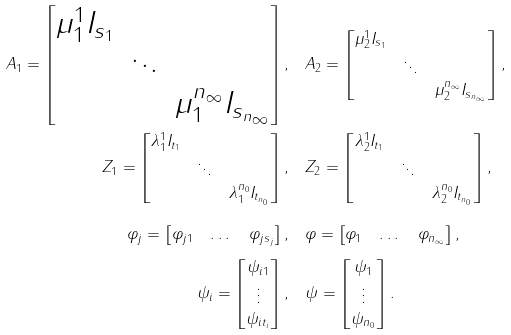<formula> <loc_0><loc_0><loc_500><loc_500>A _ { 1 } = \begin{bmatrix} \mu ^ { 1 } _ { 1 } I _ { s _ { 1 } } & & \\ & \ddots & \\ & & \mu ^ { n _ { \infty } } _ { 1 } I _ { s _ { n _ { \infty } } } \end{bmatrix} , & \quad A _ { 2 } = \begin{bmatrix} \mu ^ { 1 } _ { 2 } I _ { s _ { 1 } } & & \\ & \ddots & \\ & & \mu ^ { n _ { \infty } } _ { 2 } I _ { s _ { n _ { \infty } } } \end{bmatrix} , \\ Z _ { 1 } = \begin{bmatrix} \lambda ^ { 1 } _ { 1 } I _ { t _ { 1 } } & & \\ & \ddots & \\ & & \lambda ^ { n _ { 0 } } _ { 1 } I _ { t _ { n _ { 0 } } } \end{bmatrix} , & \quad Z _ { 2 } = \begin{bmatrix} \lambda ^ { 1 } _ { 2 } I _ { t _ { 1 } } & & \\ & \ddots & \\ & & \lambda ^ { n _ { 0 } } _ { 2 } I _ { t _ { n _ { 0 } } } \end{bmatrix} , \\ \varphi _ { j } = \begin{bmatrix} \varphi _ { j 1 } & \dots & \varphi _ { j s _ { j } } \end{bmatrix} , & \quad \varphi = \begin{bmatrix} \varphi _ { 1 } & \dots & \varphi _ { n _ { \infty } } \end{bmatrix} , \\ \psi _ { i } = \begin{bmatrix} \psi _ { i 1 } \\ \vdots \\ \psi _ { i t _ { i } } \end{bmatrix} , & \quad \psi = \begin{bmatrix} \psi _ { 1 } \\ \vdots \\ \psi _ { n _ { 0 } } \end{bmatrix} .</formula> 